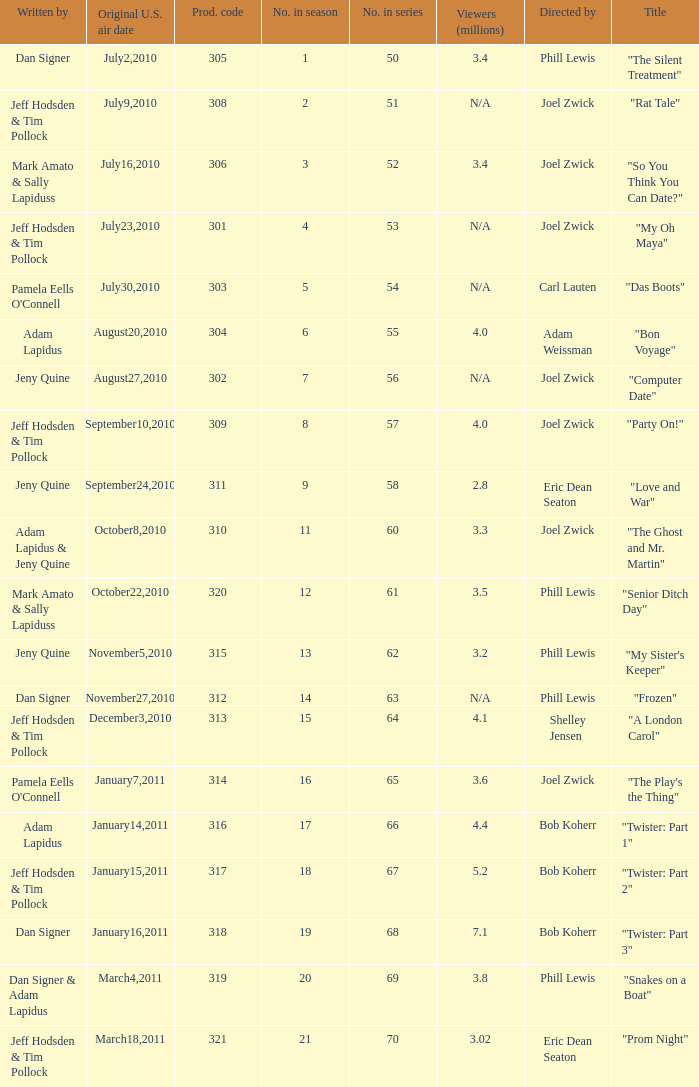How many million viewers watched episode 6? 4.0. 